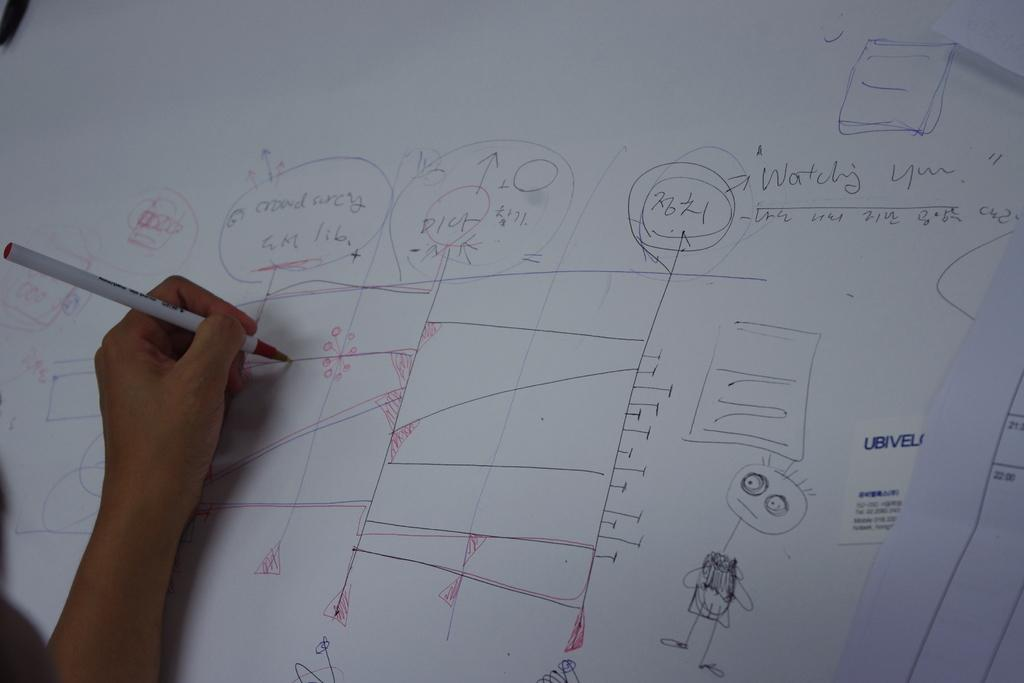<image>
Summarize the visual content of the image. A hand holding a red pen draws lines while a phrase to the right says they are watching you. 